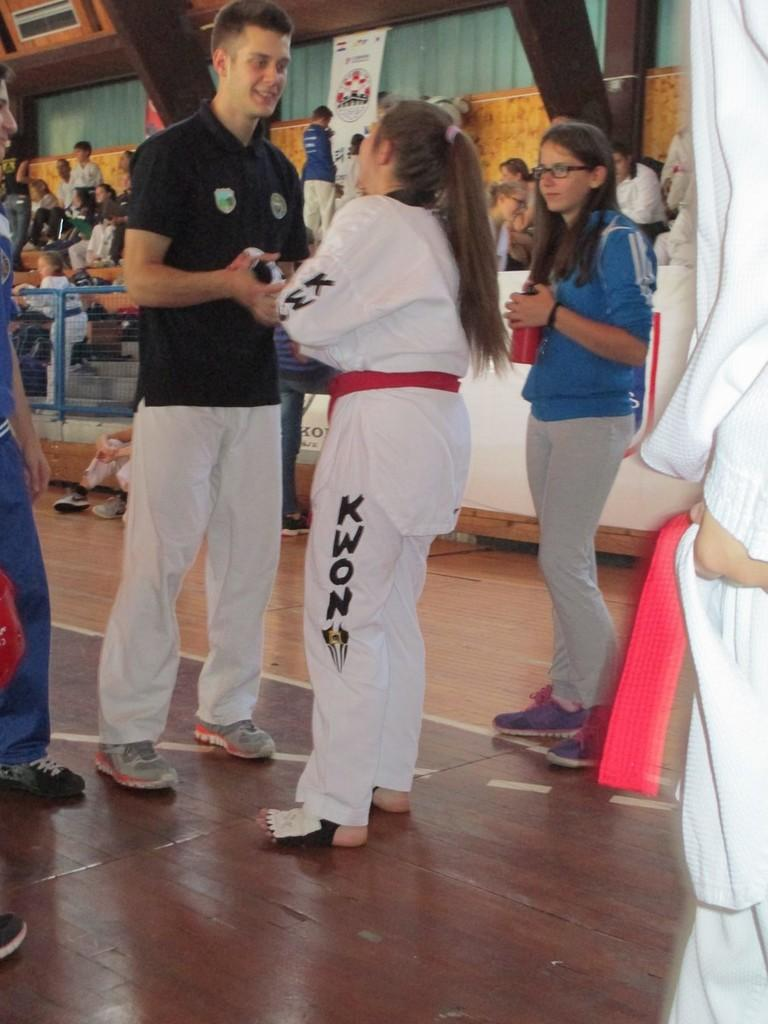<image>
Relay a brief, clear account of the picture shown. a girl that has the letters kwon on their pants 